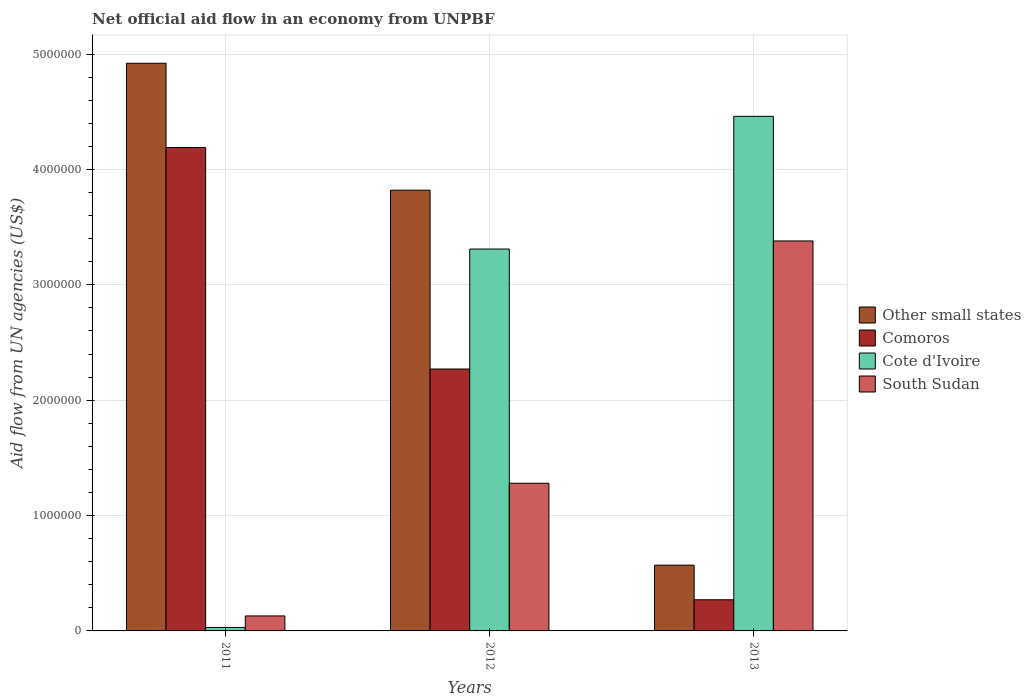How many different coloured bars are there?
Provide a short and direct response. 4. Are the number of bars per tick equal to the number of legend labels?
Keep it short and to the point. Yes. Are the number of bars on each tick of the X-axis equal?
Your response must be concise. Yes. How many bars are there on the 1st tick from the left?
Give a very brief answer. 4. In how many cases, is the number of bars for a given year not equal to the number of legend labels?
Your answer should be very brief. 0. What is the net official aid flow in Other small states in 2012?
Offer a terse response. 3.82e+06. Across all years, what is the maximum net official aid flow in Comoros?
Make the answer very short. 4.19e+06. Across all years, what is the minimum net official aid flow in Cote d'Ivoire?
Provide a short and direct response. 3.00e+04. What is the total net official aid flow in Comoros in the graph?
Keep it short and to the point. 6.73e+06. What is the difference between the net official aid flow in Cote d'Ivoire in 2011 and that in 2012?
Your response must be concise. -3.28e+06. What is the difference between the net official aid flow in Other small states in 2011 and the net official aid flow in South Sudan in 2012?
Keep it short and to the point. 3.64e+06. What is the average net official aid flow in Other small states per year?
Make the answer very short. 3.10e+06. In the year 2012, what is the difference between the net official aid flow in South Sudan and net official aid flow in Comoros?
Your answer should be compact. -9.90e+05. In how many years, is the net official aid flow in South Sudan greater than 1400000 US$?
Ensure brevity in your answer.  1. What is the ratio of the net official aid flow in South Sudan in 2012 to that in 2013?
Offer a very short reply. 0.38. Is the net official aid flow in Other small states in 2012 less than that in 2013?
Provide a succinct answer. No. Is the difference between the net official aid flow in South Sudan in 2011 and 2013 greater than the difference between the net official aid flow in Comoros in 2011 and 2013?
Offer a terse response. No. What is the difference between the highest and the second highest net official aid flow in South Sudan?
Your answer should be very brief. 2.10e+06. What is the difference between the highest and the lowest net official aid flow in Cote d'Ivoire?
Provide a short and direct response. 4.43e+06. What does the 3rd bar from the left in 2013 represents?
Offer a very short reply. Cote d'Ivoire. What does the 3rd bar from the right in 2012 represents?
Keep it short and to the point. Comoros. Is it the case that in every year, the sum of the net official aid flow in Cote d'Ivoire and net official aid flow in South Sudan is greater than the net official aid flow in Other small states?
Your response must be concise. No. How many bars are there?
Provide a succinct answer. 12. What is the difference between two consecutive major ticks on the Y-axis?
Make the answer very short. 1.00e+06. Does the graph contain grids?
Provide a short and direct response. Yes. Where does the legend appear in the graph?
Offer a very short reply. Center right. How many legend labels are there?
Make the answer very short. 4. How are the legend labels stacked?
Your answer should be very brief. Vertical. What is the title of the graph?
Provide a short and direct response. Net official aid flow in an economy from UNPBF. What is the label or title of the X-axis?
Make the answer very short. Years. What is the label or title of the Y-axis?
Your response must be concise. Aid flow from UN agencies (US$). What is the Aid flow from UN agencies (US$) of Other small states in 2011?
Make the answer very short. 4.92e+06. What is the Aid flow from UN agencies (US$) of Comoros in 2011?
Offer a very short reply. 4.19e+06. What is the Aid flow from UN agencies (US$) of Other small states in 2012?
Offer a terse response. 3.82e+06. What is the Aid flow from UN agencies (US$) of Comoros in 2012?
Your answer should be very brief. 2.27e+06. What is the Aid flow from UN agencies (US$) in Cote d'Ivoire in 2012?
Ensure brevity in your answer.  3.31e+06. What is the Aid flow from UN agencies (US$) of South Sudan in 2012?
Give a very brief answer. 1.28e+06. What is the Aid flow from UN agencies (US$) of Other small states in 2013?
Keep it short and to the point. 5.70e+05. What is the Aid flow from UN agencies (US$) of Comoros in 2013?
Ensure brevity in your answer.  2.70e+05. What is the Aid flow from UN agencies (US$) of Cote d'Ivoire in 2013?
Provide a short and direct response. 4.46e+06. What is the Aid flow from UN agencies (US$) of South Sudan in 2013?
Your answer should be compact. 3.38e+06. Across all years, what is the maximum Aid flow from UN agencies (US$) in Other small states?
Give a very brief answer. 4.92e+06. Across all years, what is the maximum Aid flow from UN agencies (US$) of Comoros?
Make the answer very short. 4.19e+06. Across all years, what is the maximum Aid flow from UN agencies (US$) of Cote d'Ivoire?
Offer a terse response. 4.46e+06. Across all years, what is the maximum Aid flow from UN agencies (US$) in South Sudan?
Make the answer very short. 3.38e+06. Across all years, what is the minimum Aid flow from UN agencies (US$) of Other small states?
Offer a very short reply. 5.70e+05. Across all years, what is the minimum Aid flow from UN agencies (US$) in Comoros?
Provide a short and direct response. 2.70e+05. Across all years, what is the minimum Aid flow from UN agencies (US$) of Cote d'Ivoire?
Your answer should be compact. 3.00e+04. What is the total Aid flow from UN agencies (US$) of Other small states in the graph?
Ensure brevity in your answer.  9.31e+06. What is the total Aid flow from UN agencies (US$) in Comoros in the graph?
Your answer should be compact. 6.73e+06. What is the total Aid flow from UN agencies (US$) in Cote d'Ivoire in the graph?
Offer a terse response. 7.80e+06. What is the total Aid flow from UN agencies (US$) of South Sudan in the graph?
Make the answer very short. 4.79e+06. What is the difference between the Aid flow from UN agencies (US$) of Other small states in 2011 and that in 2012?
Offer a very short reply. 1.10e+06. What is the difference between the Aid flow from UN agencies (US$) in Comoros in 2011 and that in 2012?
Offer a very short reply. 1.92e+06. What is the difference between the Aid flow from UN agencies (US$) of Cote d'Ivoire in 2011 and that in 2012?
Offer a very short reply. -3.28e+06. What is the difference between the Aid flow from UN agencies (US$) in South Sudan in 2011 and that in 2012?
Provide a succinct answer. -1.15e+06. What is the difference between the Aid flow from UN agencies (US$) in Other small states in 2011 and that in 2013?
Ensure brevity in your answer.  4.35e+06. What is the difference between the Aid flow from UN agencies (US$) of Comoros in 2011 and that in 2013?
Keep it short and to the point. 3.92e+06. What is the difference between the Aid flow from UN agencies (US$) in Cote d'Ivoire in 2011 and that in 2013?
Your answer should be compact. -4.43e+06. What is the difference between the Aid flow from UN agencies (US$) in South Sudan in 2011 and that in 2013?
Give a very brief answer. -3.25e+06. What is the difference between the Aid flow from UN agencies (US$) of Other small states in 2012 and that in 2013?
Provide a short and direct response. 3.25e+06. What is the difference between the Aid flow from UN agencies (US$) in Cote d'Ivoire in 2012 and that in 2013?
Keep it short and to the point. -1.15e+06. What is the difference between the Aid flow from UN agencies (US$) of South Sudan in 2012 and that in 2013?
Provide a succinct answer. -2.10e+06. What is the difference between the Aid flow from UN agencies (US$) of Other small states in 2011 and the Aid flow from UN agencies (US$) of Comoros in 2012?
Your answer should be very brief. 2.65e+06. What is the difference between the Aid flow from UN agencies (US$) of Other small states in 2011 and the Aid flow from UN agencies (US$) of Cote d'Ivoire in 2012?
Offer a very short reply. 1.61e+06. What is the difference between the Aid flow from UN agencies (US$) in Other small states in 2011 and the Aid flow from UN agencies (US$) in South Sudan in 2012?
Offer a very short reply. 3.64e+06. What is the difference between the Aid flow from UN agencies (US$) of Comoros in 2011 and the Aid flow from UN agencies (US$) of Cote d'Ivoire in 2012?
Your response must be concise. 8.80e+05. What is the difference between the Aid flow from UN agencies (US$) in Comoros in 2011 and the Aid flow from UN agencies (US$) in South Sudan in 2012?
Keep it short and to the point. 2.91e+06. What is the difference between the Aid flow from UN agencies (US$) in Cote d'Ivoire in 2011 and the Aid flow from UN agencies (US$) in South Sudan in 2012?
Your response must be concise. -1.25e+06. What is the difference between the Aid flow from UN agencies (US$) of Other small states in 2011 and the Aid flow from UN agencies (US$) of Comoros in 2013?
Make the answer very short. 4.65e+06. What is the difference between the Aid flow from UN agencies (US$) in Other small states in 2011 and the Aid flow from UN agencies (US$) in Cote d'Ivoire in 2013?
Make the answer very short. 4.60e+05. What is the difference between the Aid flow from UN agencies (US$) in Other small states in 2011 and the Aid flow from UN agencies (US$) in South Sudan in 2013?
Make the answer very short. 1.54e+06. What is the difference between the Aid flow from UN agencies (US$) in Comoros in 2011 and the Aid flow from UN agencies (US$) in South Sudan in 2013?
Provide a succinct answer. 8.10e+05. What is the difference between the Aid flow from UN agencies (US$) in Cote d'Ivoire in 2011 and the Aid flow from UN agencies (US$) in South Sudan in 2013?
Offer a terse response. -3.35e+06. What is the difference between the Aid flow from UN agencies (US$) of Other small states in 2012 and the Aid flow from UN agencies (US$) of Comoros in 2013?
Ensure brevity in your answer.  3.55e+06. What is the difference between the Aid flow from UN agencies (US$) of Other small states in 2012 and the Aid flow from UN agencies (US$) of Cote d'Ivoire in 2013?
Ensure brevity in your answer.  -6.40e+05. What is the difference between the Aid flow from UN agencies (US$) in Comoros in 2012 and the Aid flow from UN agencies (US$) in Cote d'Ivoire in 2013?
Offer a very short reply. -2.19e+06. What is the difference between the Aid flow from UN agencies (US$) of Comoros in 2012 and the Aid flow from UN agencies (US$) of South Sudan in 2013?
Ensure brevity in your answer.  -1.11e+06. What is the difference between the Aid flow from UN agencies (US$) of Cote d'Ivoire in 2012 and the Aid flow from UN agencies (US$) of South Sudan in 2013?
Make the answer very short. -7.00e+04. What is the average Aid flow from UN agencies (US$) of Other small states per year?
Keep it short and to the point. 3.10e+06. What is the average Aid flow from UN agencies (US$) of Comoros per year?
Make the answer very short. 2.24e+06. What is the average Aid flow from UN agencies (US$) of Cote d'Ivoire per year?
Offer a terse response. 2.60e+06. What is the average Aid flow from UN agencies (US$) of South Sudan per year?
Make the answer very short. 1.60e+06. In the year 2011, what is the difference between the Aid flow from UN agencies (US$) of Other small states and Aid flow from UN agencies (US$) of Comoros?
Your response must be concise. 7.30e+05. In the year 2011, what is the difference between the Aid flow from UN agencies (US$) of Other small states and Aid flow from UN agencies (US$) of Cote d'Ivoire?
Keep it short and to the point. 4.89e+06. In the year 2011, what is the difference between the Aid flow from UN agencies (US$) in Other small states and Aid flow from UN agencies (US$) in South Sudan?
Provide a short and direct response. 4.79e+06. In the year 2011, what is the difference between the Aid flow from UN agencies (US$) in Comoros and Aid flow from UN agencies (US$) in Cote d'Ivoire?
Keep it short and to the point. 4.16e+06. In the year 2011, what is the difference between the Aid flow from UN agencies (US$) of Comoros and Aid flow from UN agencies (US$) of South Sudan?
Ensure brevity in your answer.  4.06e+06. In the year 2012, what is the difference between the Aid flow from UN agencies (US$) of Other small states and Aid flow from UN agencies (US$) of Comoros?
Offer a very short reply. 1.55e+06. In the year 2012, what is the difference between the Aid flow from UN agencies (US$) of Other small states and Aid flow from UN agencies (US$) of Cote d'Ivoire?
Provide a short and direct response. 5.10e+05. In the year 2012, what is the difference between the Aid flow from UN agencies (US$) in Other small states and Aid flow from UN agencies (US$) in South Sudan?
Provide a succinct answer. 2.54e+06. In the year 2012, what is the difference between the Aid flow from UN agencies (US$) in Comoros and Aid flow from UN agencies (US$) in Cote d'Ivoire?
Ensure brevity in your answer.  -1.04e+06. In the year 2012, what is the difference between the Aid flow from UN agencies (US$) of Comoros and Aid flow from UN agencies (US$) of South Sudan?
Make the answer very short. 9.90e+05. In the year 2012, what is the difference between the Aid flow from UN agencies (US$) in Cote d'Ivoire and Aid flow from UN agencies (US$) in South Sudan?
Offer a very short reply. 2.03e+06. In the year 2013, what is the difference between the Aid flow from UN agencies (US$) of Other small states and Aid flow from UN agencies (US$) of Cote d'Ivoire?
Give a very brief answer. -3.89e+06. In the year 2013, what is the difference between the Aid flow from UN agencies (US$) in Other small states and Aid flow from UN agencies (US$) in South Sudan?
Offer a terse response. -2.81e+06. In the year 2013, what is the difference between the Aid flow from UN agencies (US$) in Comoros and Aid flow from UN agencies (US$) in Cote d'Ivoire?
Ensure brevity in your answer.  -4.19e+06. In the year 2013, what is the difference between the Aid flow from UN agencies (US$) in Comoros and Aid flow from UN agencies (US$) in South Sudan?
Give a very brief answer. -3.11e+06. In the year 2013, what is the difference between the Aid flow from UN agencies (US$) in Cote d'Ivoire and Aid flow from UN agencies (US$) in South Sudan?
Your answer should be compact. 1.08e+06. What is the ratio of the Aid flow from UN agencies (US$) of Other small states in 2011 to that in 2012?
Offer a terse response. 1.29. What is the ratio of the Aid flow from UN agencies (US$) of Comoros in 2011 to that in 2012?
Provide a succinct answer. 1.85. What is the ratio of the Aid flow from UN agencies (US$) of Cote d'Ivoire in 2011 to that in 2012?
Provide a succinct answer. 0.01. What is the ratio of the Aid flow from UN agencies (US$) in South Sudan in 2011 to that in 2012?
Offer a very short reply. 0.1. What is the ratio of the Aid flow from UN agencies (US$) of Other small states in 2011 to that in 2013?
Your answer should be very brief. 8.63. What is the ratio of the Aid flow from UN agencies (US$) of Comoros in 2011 to that in 2013?
Provide a succinct answer. 15.52. What is the ratio of the Aid flow from UN agencies (US$) of Cote d'Ivoire in 2011 to that in 2013?
Provide a short and direct response. 0.01. What is the ratio of the Aid flow from UN agencies (US$) in South Sudan in 2011 to that in 2013?
Your answer should be very brief. 0.04. What is the ratio of the Aid flow from UN agencies (US$) in Other small states in 2012 to that in 2013?
Keep it short and to the point. 6.7. What is the ratio of the Aid flow from UN agencies (US$) of Comoros in 2012 to that in 2013?
Ensure brevity in your answer.  8.41. What is the ratio of the Aid flow from UN agencies (US$) in Cote d'Ivoire in 2012 to that in 2013?
Your answer should be very brief. 0.74. What is the ratio of the Aid flow from UN agencies (US$) in South Sudan in 2012 to that in 2013?
Your response must be concise. 0.38. What is the difference between the highest and the second highest Aid flow from UN agencies (US$) of Other small states?
Offer a terse response. 1.10e+06. What is the difference between the highest and the second highest Aid flow from UN agencies (US$) of Comoros?
Ensure brevity in your answer.  1.92e+06. What is the difference between the highest and the second highest Aid flow from UN agencies (US$) of Cote d'Ivoire?
Your answer should be compact. 1.15e+06. What is the difference between the highest and the second highest Aid flow from UN agencies (US$) in South Sudan?
Give a very brief answer. 2.10e+06. What is the difference between the highest and the lowest Aid flow from UN agencies (US$) of Other small states?
Ensure brevity in your answer.  4.35e+06. What is the difference between the highest and the lowest Aid flow from UN agencies (US$) of Comoros?
Your answer should be very brief. 3.92e+06. What is the difference between the highest and the lowest Aid flow from UN agencies (US$) of Cote d'Ivoire?
Provide a short and direct response. 4.43e+06. What is the difference between the highest and the lowest Aid flow from UN agencies (US$) of South Sudan?
Give a very brief answer. 3.25e+06. 